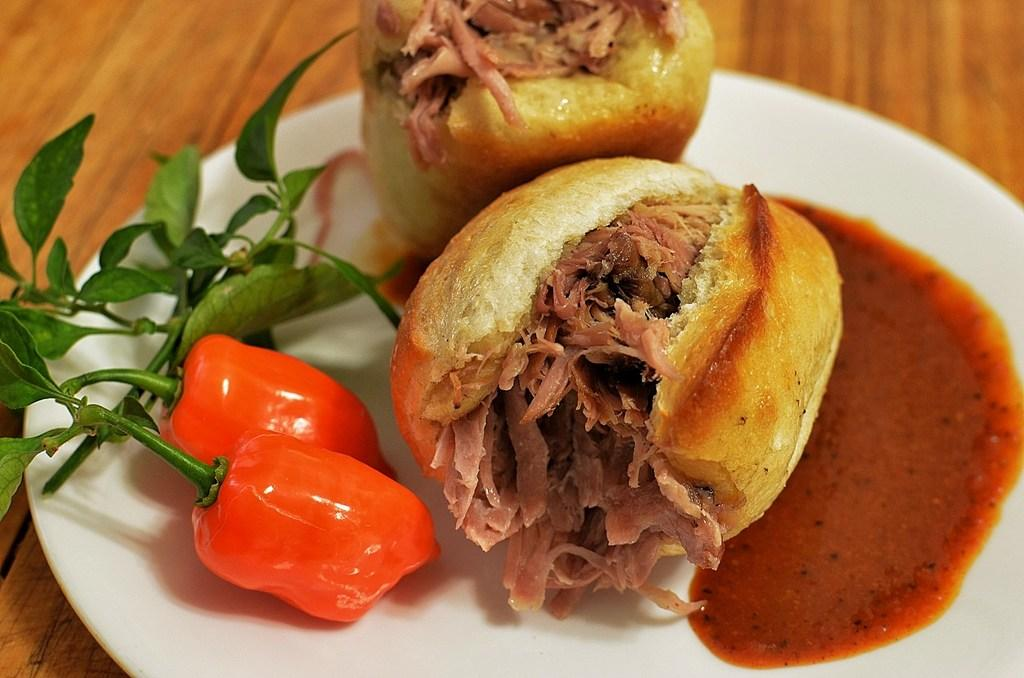What is on the plate in the image? There is a food item on a plate in the image. Where is the plate located? The plate is on a wooden table. What is the purpose of the stamp in the image? There is no stamp present in the image. 